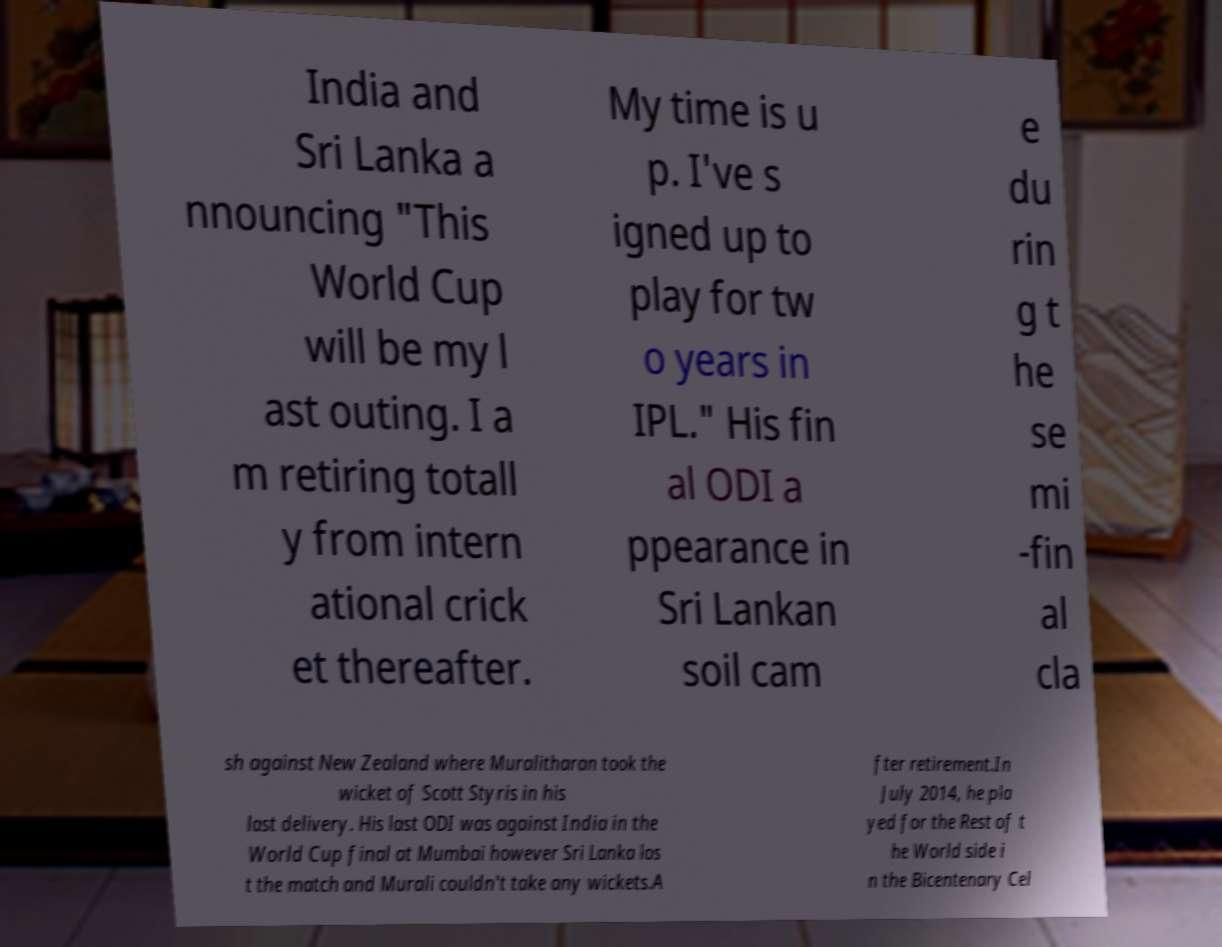Please read and relay the text visible in this image. What does it say? India and Sri Lanka a nnouncing "This World Cup will be my l ast outing. I a m retiring totall y from intern ational crick et thereafter. My time is u p. I've s igned up to play for tw o years in IPL." His fin al ODI a ppearance in Sri Lankan soil cam e du rin g t he se mi -fin al cla sh against New Zealand where Muralitharan took the wicket of Scott Styris in his last delivery. His last ODI was against India in the World Cup final at Mumbai however Sri Lanka los t the match and Murali couldn't take any wickets.A fter retirement.In July 2014, he pla yed for the Rest of t he World side i n the Bicentenary Cel 